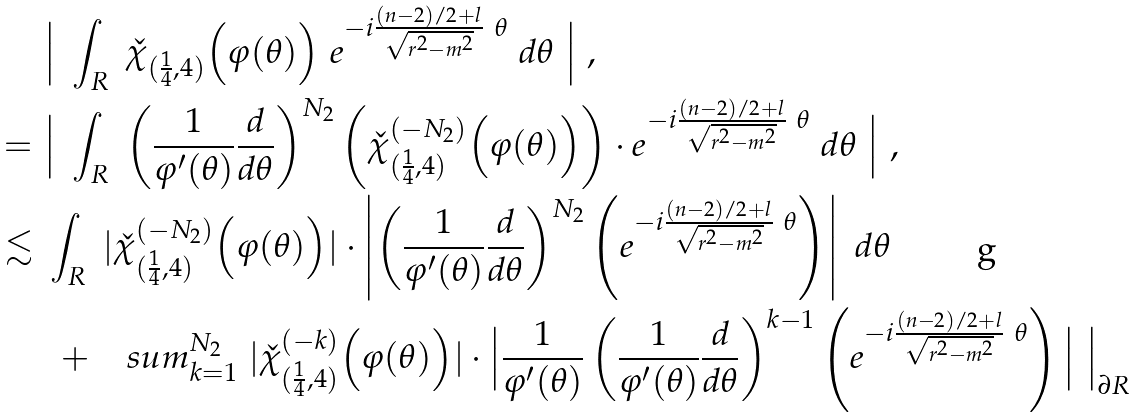<formula> <loc_0><loc_0><loc_500><loc_500>& \Big | \ \int _ { R } \ \check { \chi } _ { ( \frac { 1 } { 4 } , 4 ) } \Big ( \varphi ( \theta ) \Big ) \ e ^ { - i \frac { ( n - 2 ) / 2 + l } { \sqrt { r ^ { 2 } - m ^ { 2 } } } \ \theta } \ d \theta \ \Big | \ , \\ = \ & \Big | \ \int _ { R } \ \left ( \frac { 1 } { \varphi ^ { \prime } ( \theta ) } \frac { d } { d \theta } \right ) ^ { N _ { 2 } } \left ( \check { \chi } ^ { ( - N _ { 2 } ) } _ { ( \frac { 1 } { 4 } , 4 ) } \Big ( \varphi ( \theta ) \Big ) \right ) \cdot e ^ { - i \frac { ( n - 2 ) / 2 + l } { \sqrt { r ^ { 2 } - m ^ { 2 } } } \ \theta } \ d \theta \ \Big | \ , \\ \lesssim \ & \int _ { R } \ | \check { \chi } ^ { ( - N _ { 2 } ) } _ { ( \frac { 1 } { 4 } , 4 ) } \Big ( \varphi ( \theta ) \Big ) | \cdot \left | \left ( \frac { 1 } { \varphi ^ { \prime } ( \theta ) } \frac { d } { d \theta } \right ) ^ { N _ { 2 } } \left ( e ^ { - i \frac { ( n - 2 ) / 2 + l } { \sqrt { r ^ { 2 } - m ^ { 2 } } } \ \theta } \right ) \right | \ d \theta \\ & \ + \ \ \ s u m _ { k = 1 } ^ { N _ { 2 } } \ | \check { \chi } ^ { ( - k ) } _ { ( \frac { 1 } { 4 } , 4 ) } \Big ( \varphi ( \theta ) \Big ) | \cdot \Big | \frac { 1 } { \varphi ^ { \prime } ( \theta ) } \left ( \frac { 1 } { \varphi ^ { \prime } ( \theta ) } \frac { d } { d \theta } \right ) ^ { k - 1 } \left ( e ^ { - i \frac { ( n - 2 ) / 2 + l } { \sqrt { r ^ { 2 } - m ^ { 2 } } } \ \theta } \right ) \Big | \ \Big | _ { \partial R }</formula> 